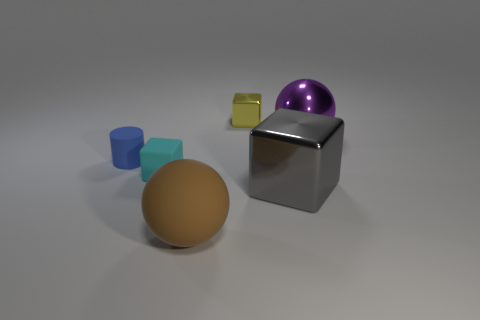Are the big gray thing and the tiny yellow block made of the same material? While it's not possible to definitively determine the materials just by this image, the big gray object and the tiny yellow block do not necessarily appear to be made of the same material. The gray object has a reflective metal-like surface, while the yellow block looks like it could be a matte plastic. 